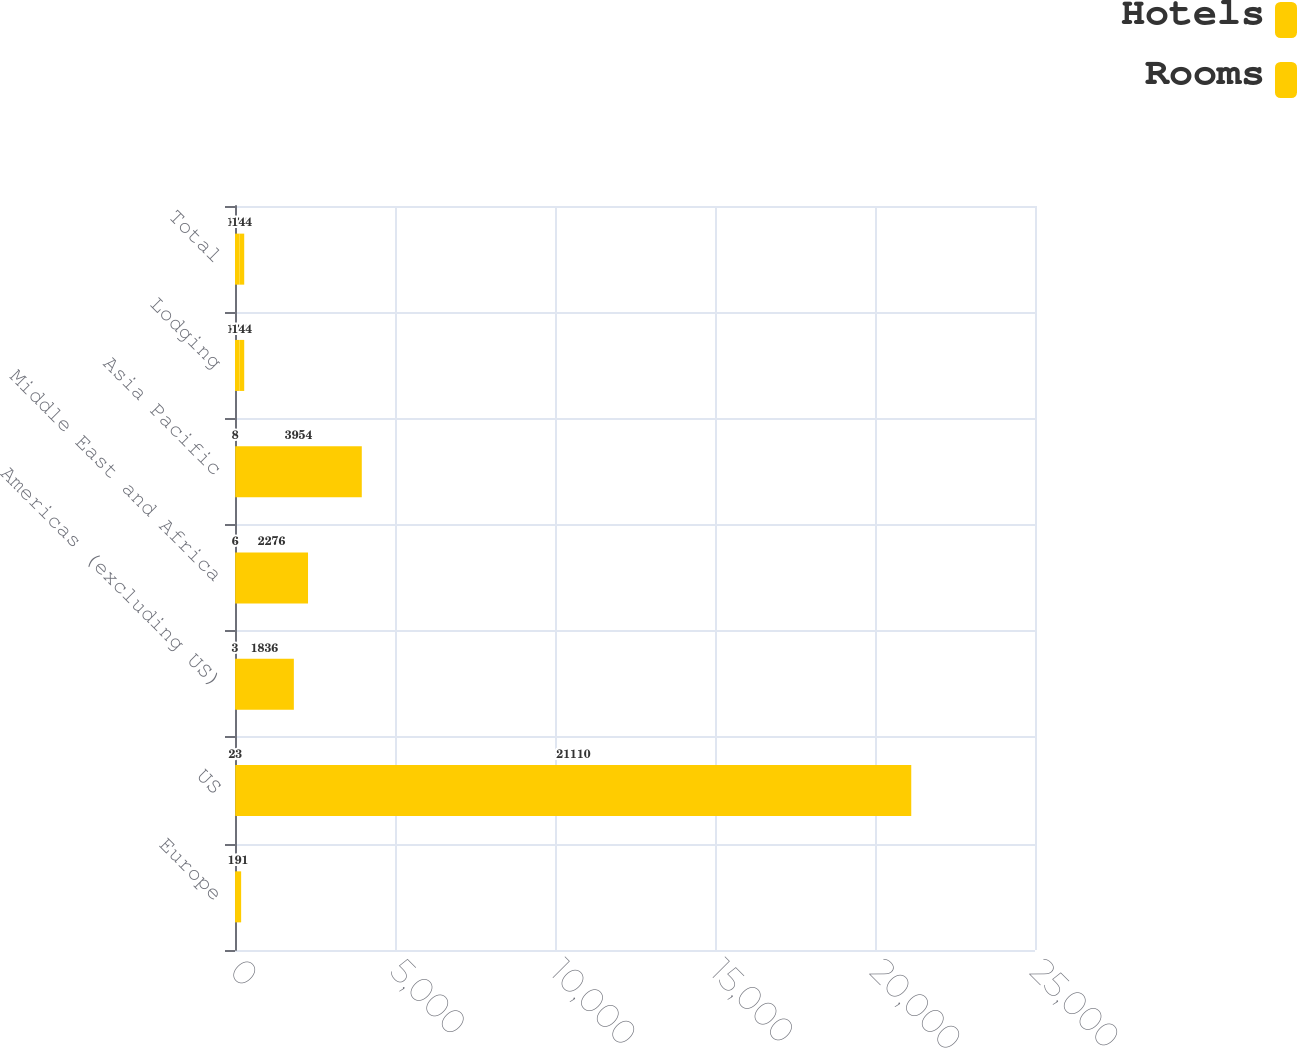<chart> <loc_0><loc_0><loc_500><loc_500><stacked_bar_chart><ecel><fcel>Europe<fcel>US<fcel>Americas (excluding US)<fcel>Middle East and Africa<fcel>Asia Pacific<fcel>Lodging<fcel>Total<nl><fcel>Hotels<fcel>1<fcel>23<fcel>3<fcel>6<fcel>8<fcel>144<fcel>144<nl><fcel>Rooms<fcel>191<fcel>21110<fcel>1836<fcel>2276<fcel>3954<fcel>144<fcel>144<nl></chart> 